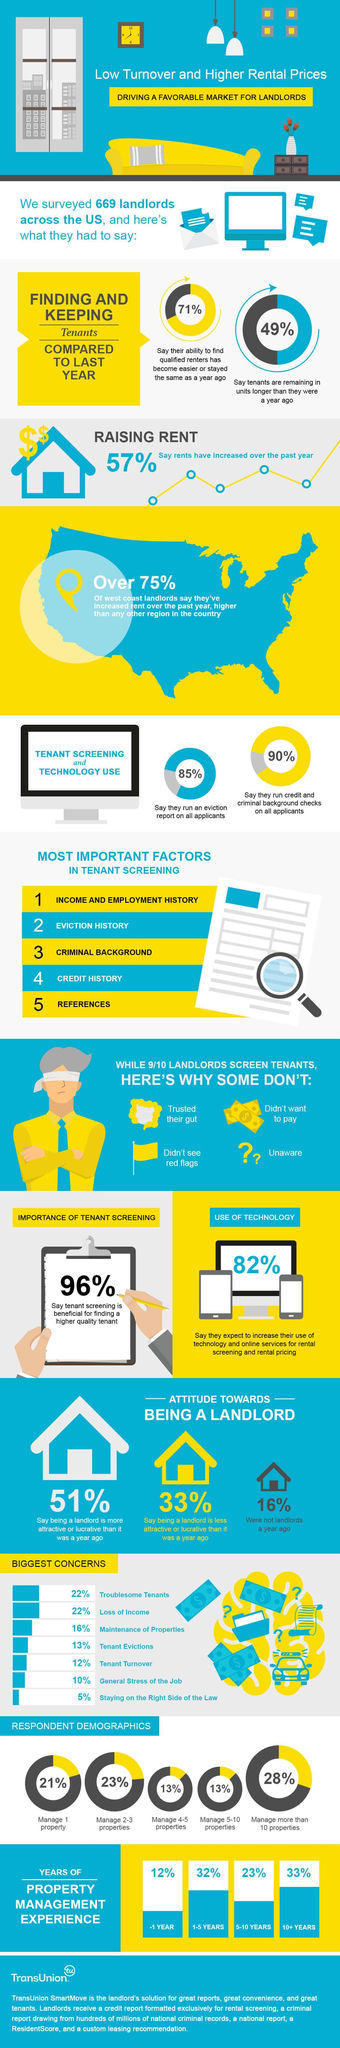what % do not run an eviction report on applicants
Answer the question with a short phrase. 15 how many % find tenant turnover and tenant eviction the biggest concern 25 how many reasons are there for landlords not screening their tenants 4 what is the third main concern of landlords maintenance of properties have many % have not found the rents increasing over the past year 43 How many were not landlards are year ago 16% how many have found it easier to find qualified renters 71% 